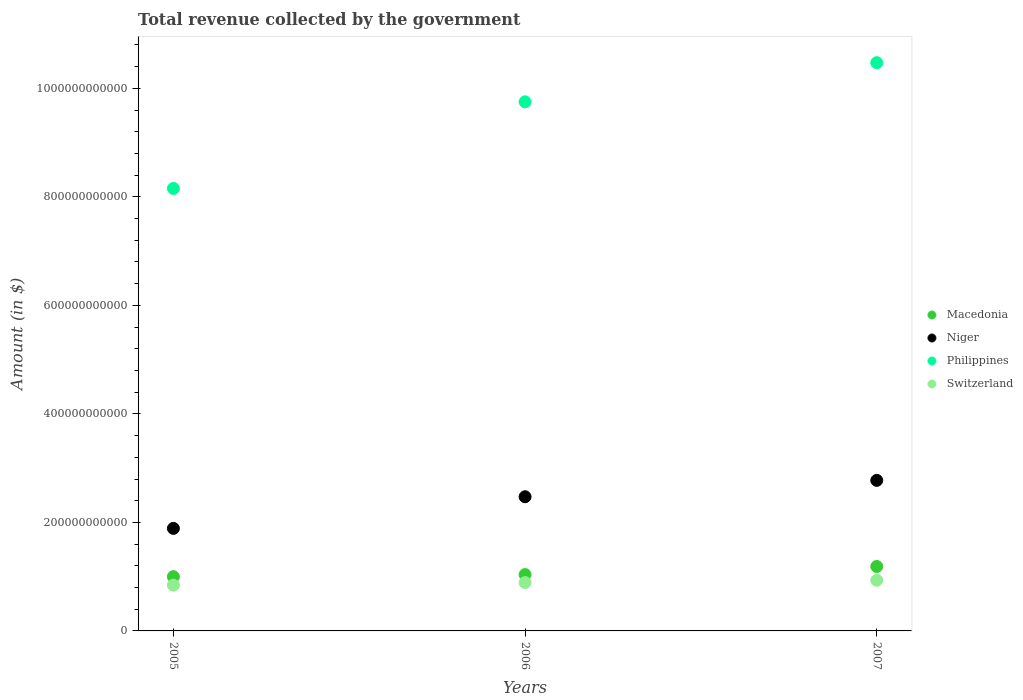Is the number of dotlines equal to the number of legend labels?
Ensure brevity in your answer.  Yes. What is the total revenue collected by the government in Philippines in 2007?
Make the answer very short. 1.05e+12. Across all years, what is the maximum total revenue collected by the government in Switzerland?
Make the answer very short. 9.34e+1. Across all years, what is the minimum total revenue collected by the government in Switzerland?
Provide a succinct answer. 8.44e+1. In which year was the total revenue collected by the government in Niger maximum?
Your answer should be very brief. 2007. In which year was the total revenue collected by the government in Niger minimum?
Keep it short and to the point. 2005. What is the total total revenue collected by the government in Niger in the graph?
Keep it short and to the point. 7.14e+11. What is the difference between the total revenue collected by the government in Switzerland in 2006 and that in 2007?
Your answer should be compact. -4.24e+09. What is the difference between the total revenue collected by the government in Macedonia in 2005 and the total revenue collected by the government in Switzerland in 2007?
Provide a succinct answer. 6.61e+09. What is the average total revenue collected by the government in Macedonia per year?
Your response must be concise. 1.08e+11. In the year 2007, what is the difference between the total revenue collected by the government in Niger and total revenue collected by the government in Philippines?
Your response must be concise. -7.70e+11. In how many years, is the total revenue collected by the government in Niger greater than 840000000000 $?
Your response must be concise. 0. What is the ratio of the total revenue collected by the government in Niger in 2005 to that in 2007?
Keep it short and to the point. 0.68. What is the difference between the highest and the second highest total revenue collected by the government in Macedonia?
Give a very brief answer. 1.50e+1. What is the difference between the highest and the lowest total revenue collected by the government in Philippines?
Ensure brevity in your answer.  2.32e+11. In how many years, is the total revenue collected by the government in Niger greater than the average total revenue collected by the government in Niger taken over all years?
Your response must be concise. 2. Does the total revenue collected by the government in Philippines monotonically increase over the years?
Your response must be concise. Yes. Is the total revenue collected by the government in Switzerland strictly greater than the total revenue collected by the government in Macedonia over the years?
Make the answer very short. No. Is the total revenue collected by the government in Niger strictly less than the total revenue collected by the government in Switzerland over the years?
Your response must be concise. No. What is the difference between two consecutive major ticks on the Y-axis?
Provide a succinct answer. 2.00e+11. Does the graph contain any zero values?
Ensure brevity in your answer.  No. Does the graph contain grids?
Your response must be concise. No. Where does the legend appear in the graph?
Your response must be concise. Center right. How are the legend labels stacked?
Give a very brief answer. Vertical. What is the title of the graph?
Your answer should be very brief. Total revenue collected by the government. Does "Czech Republic" appear as one of the legend labels in the graph?
Keep it short and to the point. No. What is the label or title of the Y-axis?
Provide a succinct answer. Amount (in $). What is the Amount (in $) of Macedonia in 2005?
Your answer should be compact. 1.00e+11. What is the Amount (in $) in Niger in 2005?
Ensure brevity in your answer.  1.89e+11. What is the Amount (in $) in Philippines in 2005?
Make the answer very short. 8.16e+11. What is the Amount (in $) in Switzerland in 2005?
Your answer should be very brief. 8.44e+1. What is the Amount (in $) of Macedonia in 2006?
Provide a short and direct response. 1.04e+11. What is the Amount (in $) in Niger in 2006?
Offer a very short reply. 2.47e+11. What is the Amount (in $) of Philippines in 2006?
Keep it short and to the point. 9.75e+11. What is the Amount (in $) of Switzerland in 2006?
Ensure brevity in your answer.  8.91e+1. What is the Amount (in $) in Macedonia in 2007?
Your answer should be very brief. 1.19e+11. What is the Amount (in $) of Niger in 2007?
Provide a succinct answer. 2.78e+11. What is the Amount (in $) in Philippines in 2007?
Your answer should be compact. 1.05e+12. What is the Amount (in $) in Switzerland in 2007?
Provide a succinct answer. 9.34e+1. Across all years, what is the maximum Amount (in $) of Macedonia?
Provide a succinct answer. 1.19e+11. Across all years, what is the maximum Amount (in $) of Niger?
Offer a terse response. 2.78e+11. Across all years, what is the maximum Amount (in $) of Philippines?
Your answer should be compact. 1.05e+12. Across all years, what is the maximum Amount (in $) in Switzerland?
Your answer should be compact. 9.34e+1. Across all years, what is the minimum Amount (in $) of Macedonia?
Ensure brevity in your answer.  1.00e+11. Across all years, what is the minimum Amount (in $) of Niger?
Offer a very short reply. 1.89e+11. Across all years, what is the minimum Amount (in $) of Philippines?
Give a very brief answer. 8.16e+11. Across all years, what is the minimum Amount (in $) of Switzerland?
Offer a terse response. 8.44e+1. What is the total Amount (in $) of Macedonia in the graph?
Ensure brevity in your answer.  3.23e+11. What is the total Amount (in $) of Niger in the graph?
Provide a succinct answer. 7.14e+11. What is the total Amount (in $) in Philippines in the graph?
Your answer should be very brief. 2.84e+12. What is the total Amount (in $) in Switzerland in the graph?
Keep it short and to the point. 2.67e+11. What is the difference between the Amount (in $) in Macedonia in 2005 and that in 2006?
Keep it short and to the point. -3.82e+09. What is the difference between the Amount (in $) in Niger in 2005 and that in 2006?
Your answer should be compact. -5.83e+1. What is the difference between the Amount (in $) in Philippines in 2005 and that in 2006?
Your answer should be very brief. -1.60e+11. What is the difference between the Amount (in $) of Switzerland in 2005 and that in 2006?
Your response must be concise. -4.74e+09. What is the difference between the Amount (in $) in Macedonia in 2005 and that in 2007?
Offer a very short reply. -1.88e+1. What is the difference between the Amount (in $) in Niger in 2005 and that in 2007?
Give a very brief answer. -8.85e+1. What is the difference between the Amount (in $) in Philippines in 2005 and that in 2007?
Provide a short and direct response. -2.32e+11. What is the difference between the Amount (in $) in Switzerland in 2005 and that in 2007?
Offer a very short reply. -8.99e+09. What is the difference between the Amount (in $) of Macedonia in 2006 and that in 2007?
Keep it short and to the point. -1.50e+1. What is the difference between the Amount (in $) in Niger in 2006 and that in 2007?
Provide a succinct answer. -3.02e+1. What is the difference between the Amount (in $) in Philippines in 2006 and that in 2007?
Your answer should be compact. -7.21e+1. What is the difference between the Amount (in $) in Switzerland in 2006 and that in 2007?
Provide a short and direct response. -4.24e+09. What is the difference between the Amount (in $) in Macedonia in 2005 and the Amount (in $) in Niger in 2006?
Provide a succinct answer. -1.47e+11. What is the difference between the Amount (in $) in Macedonia in 2005 and the Amount (in $) in Philippines in 2006?
Ensure brevity in your answer.  -8.75e+11. What is the difference between the Amount (in $) of Macedonia in 2005 and the Amount (in $) of Switzerland in 2006?
Provide a succinct answer. 1.09e+1. What is the difference between the Amount (in $) in Niger in 2005 and the Amount (in $) in Philippines in 2006?
Provide a short and direct response. -7.86e+11. What is the difference between the Amount (in $) of Niger in 2005 and the Amount (in $) of Switzerland in 2006?
Your answer should be compact. 9.98e+1. What is the difference between the Amount (in $) in Philippines in 2005 and the Amount (in $) in Switzerland in 2006?
Make the answer very short. 7.26e+11. What is the difference between the Amount (in $) of Macedonia in 2005 and the Amount (in $) of Niger in 2007?
Keep it short and to the point. -1.78e+11. What is the difference between the Amount (in $) of Macedonia in 2005 and the Amount (in $) of Philippines in 2007?
Offer a very short reply. -9.47e+11. What is the difference between the Amount (in $) in Macedonia in 2005 and the Amount (in $) in Switzerland in 2007?
Keep it short and to the point. 6.61e+09. What is the difference between the Amount (in $) in Niger in 2005 and the Amount (in $) in Philippines in 2007?
Keep it short and to the point. -8.58e+11. What is the difference between the Amount (in $) in Niger in 2005 and the Amount (in $) in Switzerland in 2007?
Ensure brevity in your answer.  9.56e+1. What is the difference between the Amount (in $) of Philippines in 2005 and the Amount (in $) of Switzerland in 2007?
Ensure brevity in your answer.  7.22e+11. What is the difference between the Amount (in $) of Macedonia in 2006 and the Amount (in $) of Niger in 2007?
Offer a terse response. -1.74e+11. What is the difference between the Amount (in $) of Macedonia in 2006 and the Amount (in $) of Philippines in 2007?
Offer a very short reply. -9.44e+11. What is the difference between the Amount (in $) in Macedonia in 2006 and the Amount (in $) in Switzerland in 2007?
Make the answer very short. 1.04e+1. What is the difference between the Amount (in $) of Niger in 2006 and the Amount (in $) of Philippines in 2007?
Offer a very short reply. -8.00e+11. What is the difference between the Amount (in $) of Niger in 2006 and the Amount (in $) of Switzerland in 2007?
Ensure brevity in your answer.  1.54e+11. What is the difference between the Amount (in $) of Philippines in 2006 and the Amount (in $) of Switzerland in 2007?
Offer a very short reply. 8.82e+11. What is the average Amount (in $) of Macedonia per year?
Ensure brevity in your answer.  1.08e+11. What is the average Amount (in $) of Niger per year?
Keep it short and to the point. 2.38e+11. What is the average Amount (in $) in Philippines per year?
Give a very brief answer. 9.46e+11. What is the average Amount (in $) in Switzerland per year?
Make the answer very short. 8.90e+1. In the year 2005, what is the difference between the Amount (in $) in Macedonia and Amount (in $) in Niger?
Offer a very short reply. -8.90e+1. In the year 2005, what is the difference between the Amount (in $) in Macedonia and Amount (in $) in Philippines?
Offer a very short reply. -7.16e+11. In the year 2005, what is the difference between the Amount (in $) of Macedonia and Amount (in $) of Switzerland?
Offer a very short reply. 1.56e+1. In the year 2005, what is the difference between the Amount (in $) in Niger and Amount (in $) in Philippines?
Give a very brief answer. -6.27e+11. In the year 2005, what is the difference between the Amount (in $) of Niger and Amount (in $) of Switzerland?
Provide a short and direct response. 1.05e+11. In the year 2005, what is the difference between the Amount (in $) in Philippines and Amount (in $) in Switzerland?
Your answer should be compact. 7.31e+11. In the year 2006, what is the difference between the Amount (in $) of Macedonia and Amount (in $) of Niger?
Your answer should be compact. -1.44e+11. In the year 2006, what is the difference between the Amount (in $) in Macedonia and Amount (in $) in Philippines?
Keep it short and to the point. -8.71e+11. In the year 2006, what is the difference between the Amount (in $) in Macedonia and Amount (in $) in Switzerland?
Ensure brevity in your answer.  1.47e+1. In the year 2006, what is the difference between the Amount (in $) in Niger and Amount (in $) in Philippines?
Your answer should be very brief. -7.28e+11. In the year 2006, what is the difference between the Amount (in $) of Niger and Amount (in $) of Switzerland?
Provide a succinct answer. 1.58e+11. In the year 2006, what is the difference between the Amount (in $) of Philippines and Amount (in $) of Switzerland?
Your answer should be very brief. 8.86e+11. In the year 2007, what is the difference between the Amount (in $) of Macedonia and Amount (in $) of Niger?
Ensure brevity in your answer.  -1.59e+11. In the year 2007, what is the difference between the Amount (in $) in Macedonia and Amount (in $) in Philippines?
Offer a very short reply. -9.29e+11. In the year 2007, what is the difference between the Amount (in $) in Macedonia and Amount (in $) in Switzerland?
Give a very brief answer. 2.54e+1. In the year 2007, what is the difference between the Amount (in $) in Niger and Amount (in $) in Philippines?
Make the answer very short. -7.70e+11. In the year 2007, what is the difference between the Amount (in $) in Niger and Amount (in $) in Switzerland?
Give a very brief answer. 1.84e+11. In the year 2007, what is the difference between the Amount (in $) in Philippines and Amount (in $) in Switzerland?
Make the answer very short. 9.54e+11. What is the ratio of the Amount (in $) of Macedonia in 2005 to that in 2006?
Your answer should be compact. 0.96. What is the ratio of the Amount (in $) in Niger in 2005 to that in 2006?
Offer a terse response. 0.76. What is the ratio of the Amount (in $) in Philippines in 2005 to that in 2006?
Your answer should be compact. 0.84. What is the ratio of the Amount (in $) of Switzerland in 2005 to that in 2006?
Your answer should be compact. 0.95. What is the ratio of the Amount (in $) in Macedonia in 2005 to that in 2007?
Offer a very short reply. 0.84. What is the ratio of the Amount (in $) in Niger in 2005 to that in 2007?
Your answer should be compact. 0.68. What is the ratio of the Amount (in $) in Philippines in 2005 to that in 2007?
Offer a terse response. 0.78. What is the ratio of the Amount (in $) in Switzerland in 2005 to that in 2007?
Keep it short and to the point. 0.9. What is the ratio of the Amount (in $) of Macedonia in 2006 to that in 2007?
Provide a short and direct response. 0.87. What is the ratio of the Amount (in $) of Niger in 2006 to that in 2007?
Your response must be concise. 0.89. What is the ratio of the Amount (in $) in Philippines in 2006 to that in 2007?
Your answer should be compact. 0.93. What is the ratio of the Amount (in $) of Switzerland in 2006 to that in 2007?
Make the answer very short. 0.95. What is the difference between the highest and the second highest Amount (in $) in Macedonia?
Ensure brevity in your answer.  1.50e+1. What is the difference between the highest and the second highest Amount (in $) in Niger?
Your response must be concise. 3.02e+1. What is the difference between the highest and the second highest Amount (in $) of Philippines?
Your answer should be very brief. 7.21e+1. What is the difference between the highest and the second highest Amount (in $) of Switzerland?
Offer a terse response. 4.24e+09. What is the difference between the highest and the lowest Amount (in $) in Macedonia?
Provide a short and direct response. 1.88e+1. What is the difference between the highest and the lowest Amount (in $) of Niger?
Offer a terse response. 8.85e+1. What is the difference between the highest and the lowest Amount (in $) in Philippines?
Keep it short and to the point. 2.32e+11. What is the difference between the highest and the lowest Amount (in $) in Switzerland?
Keep it short and to the point. 8.99e+09. 